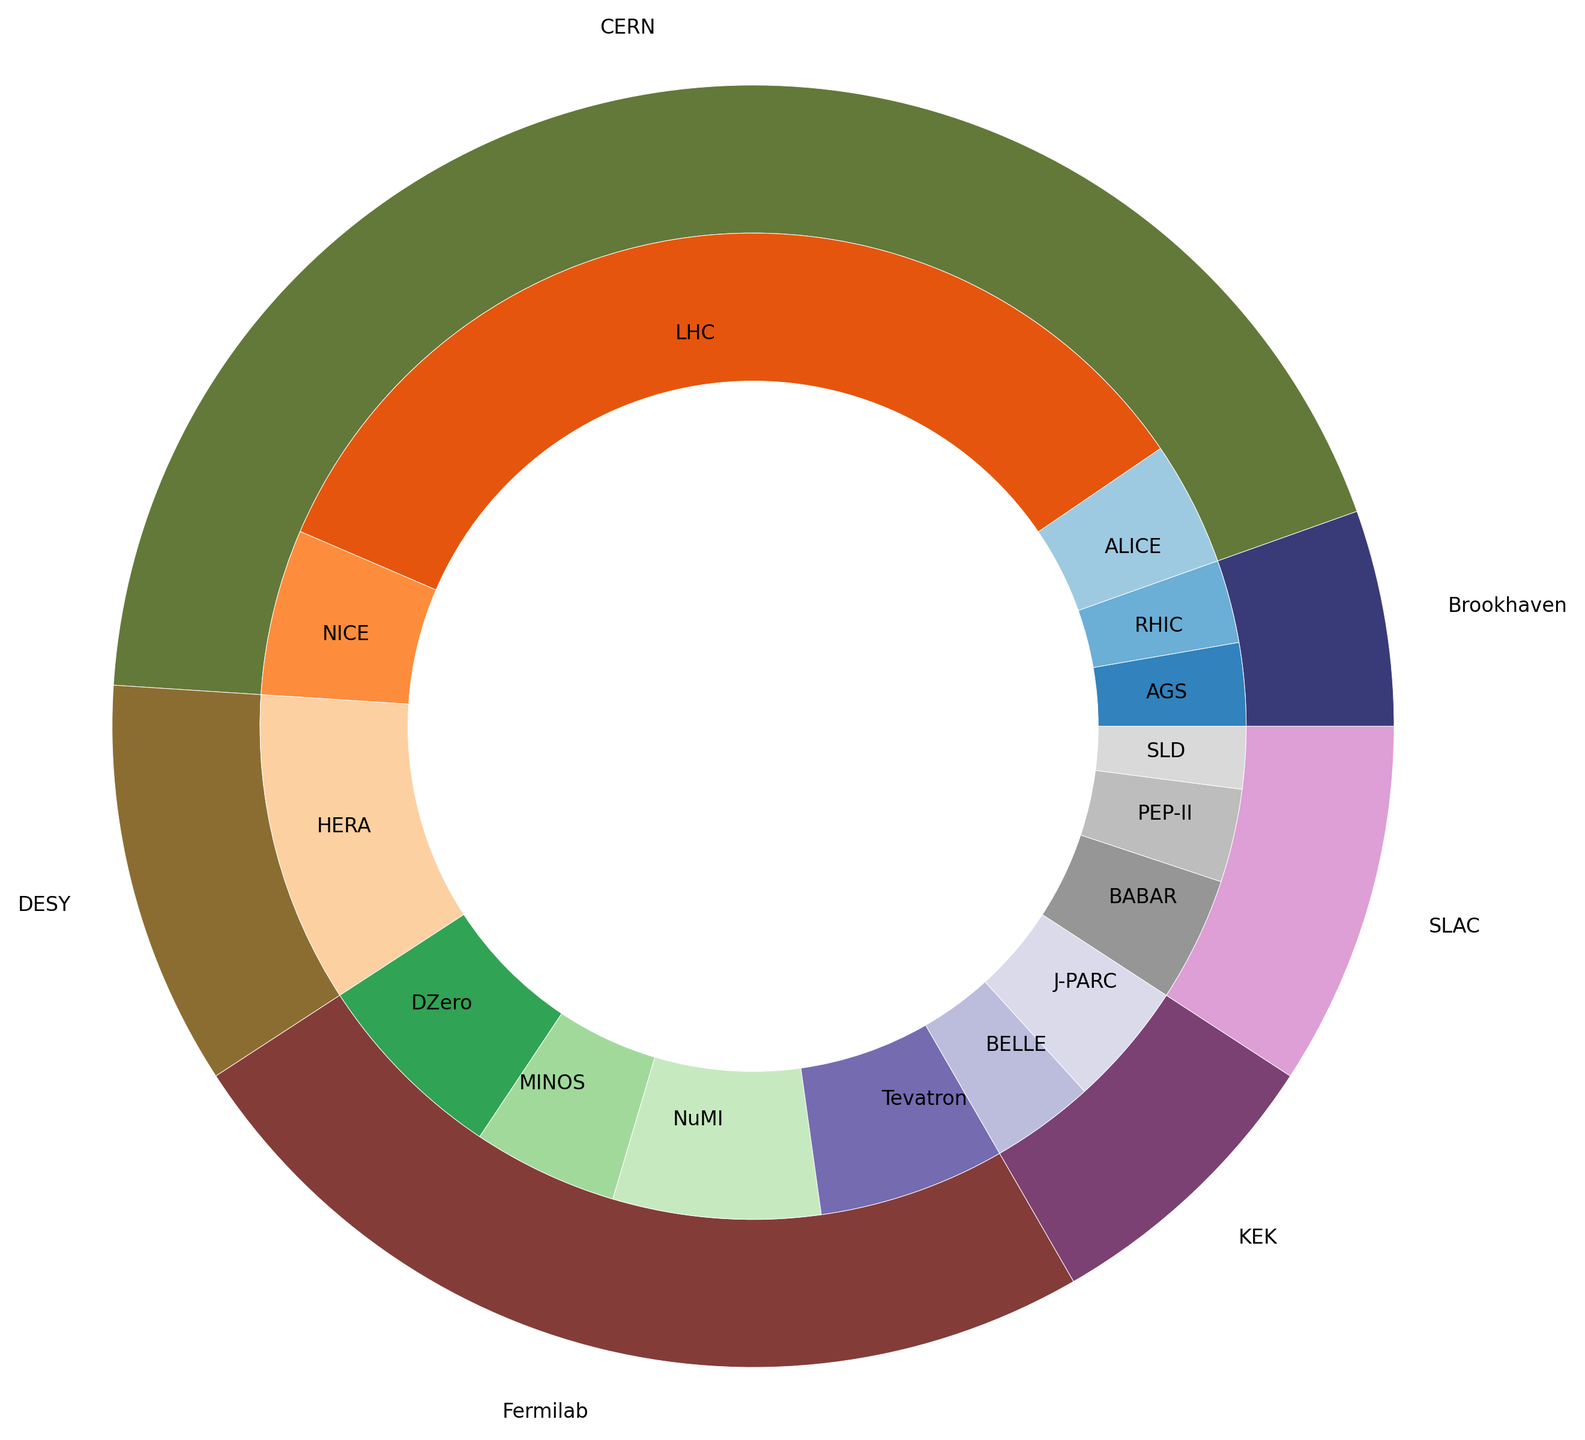Which institution discovered the most particles? The outer pie chart shows that CERN has the largest proportion of particle discoveries among the institutions.
Answer: CERN What is the total number of particles discovered by Fermilab? By looking at Fermilab’s segments in the inner pie showing different experiments, and summing up the counts (Tevatron: 90, NuMI: 100, MINOS: 70, DZero: 95), we get 90 + 100 + 70 + 95 = 355.
Answer: 355 Which experiment at CERN contributed the most to its particle discoveries? The inner pie chart segments within CERN’s section show that LHC has the largest contribution compared to other experiments.
Answer: LHC By how much does the LHC’s contribution exceed the contribution of SLAC's experiments combined? The LHC’s contributions (120 + 110 + 90 + 100 + 80) sum to 500, while SLAC’s (BABAR: 60, SLD: 30, PEP-II: 45) sum to 135. The difference is 500 - 135.
Answer: 365 What is the ratio of B Mesons discovered by CERN compared to SLAC? CERN's LHC discovered 110 B Mesons, and SLAC's BABAR discovered 60 B Mesons. The ratio is 110/60.
Answer: 11:6 Which institution has the smallest number of particle discoveries noted in the chart? The smallest segment in the outer pie corresponds to Brookhaven.
Answer: Brookhaven Are there more Quark-Gluon Plasma discoveries combined at CERN and Brookhaven than Neutrinos at Fermilab? Summing Quark-Gluon Plasma at CERN (80 from NICE, 60 from ALICE) and Brookhaven (40 from RHIC) gives 80 + 60 + 40 = 180. Fermilab’s neutrinos from NuMI and MINOS add up to 100 + 70 = 170. Hence, 180 > 170.
Answer: Yes What proportion of DESY’s particle discoveries are related to HERA? DESY’s total count is 150 (HERA: Gluon 50, Neutral Current 45, Charged Current 55). HERA’s contribution is (50 + 45 + 55) = 150, and the proportion is 150/150 = 1.0 or 100%.
Answer: 100% Which experiment is responsible for discovering the neutral current, and which institution conducted it? The inner pie chart shows that Neutral Current was discovered by DESY’s HERA experiment.
Answer: HERA, DESY How many more particles were discovered by the LHC experiment compared to BELLE at KEK? LHC’s total contribution is (120 Higgs Boson + 110 B Mesons + 90 W Boson + 100 Z Boson + 80 Charm Quark) which sums to 500. BELLE discovered 50 Hadrons. The difference is 500 - 50.
Answer: 450 